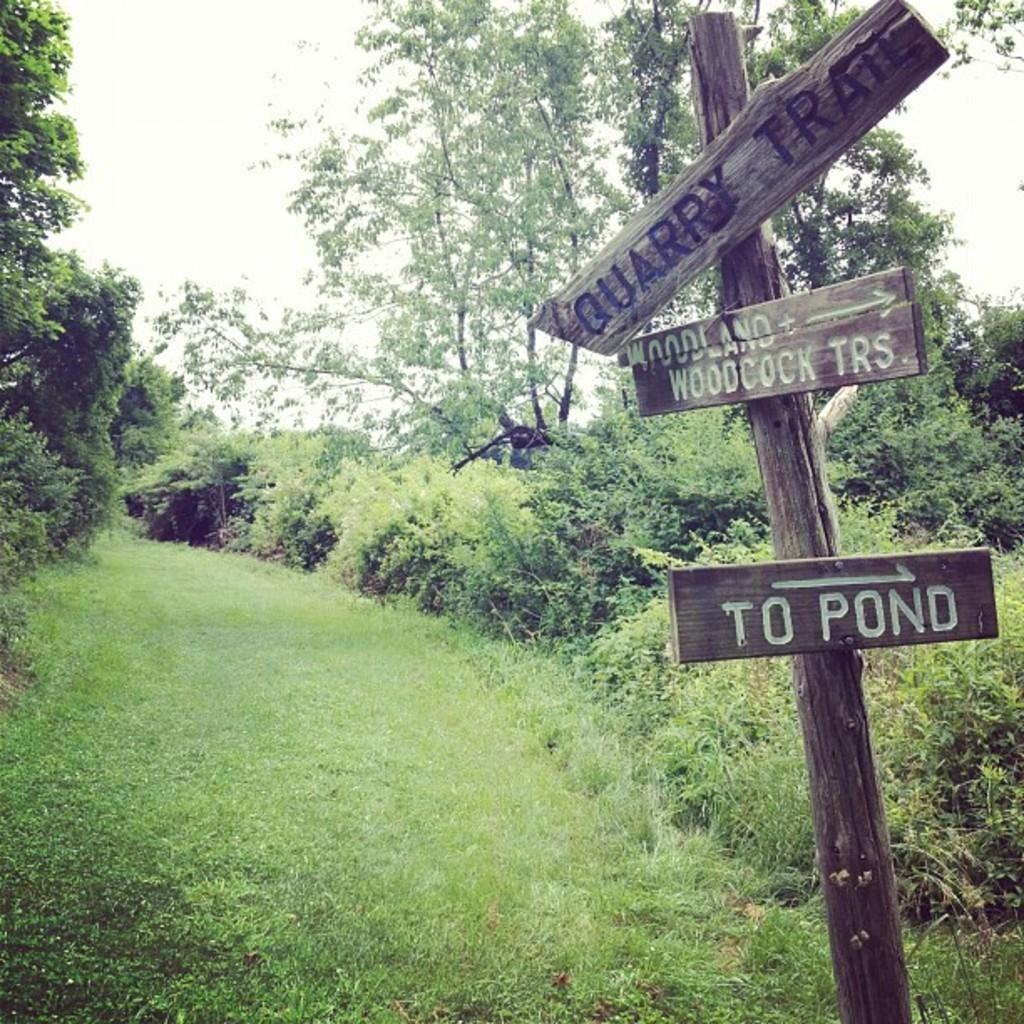What is the main object in the image? There is a wooden log in the image. What is attached to the wooden log? There are boards attached to the wooden log. What type of vegetation can be seen in the image? There is grass and plants visible in the image. What can be seen in the background of the image? There are trees and the sky visible in the background of the image. What type of brass instrument is being played in the image? There is no brass instrument present in the image; it features a wooden log with boards attached. What noise can be heard coming from the wooden log in the image? The wooden log in the image is not making any noise, as it is a static object. 